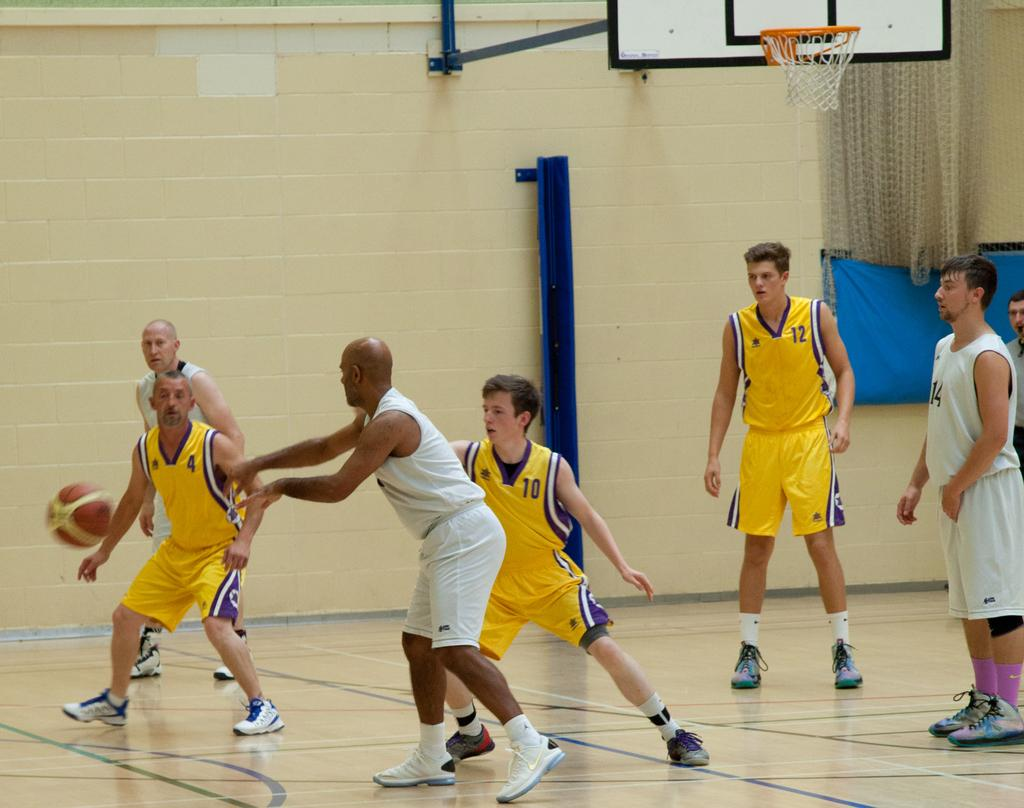How many people are in the image? There is a group of people in the image. What object is present in the image that is often used in sports? There is a ball in the image, which is commonly used in sports. What type of structure is visible in the image that is often used for basketball? There is a basketball hoop in the image. What type of architectural feature is present in the image? There is a wall in the image. What type of carriage can be seen in the image? There is no carriage present in the image. How does the group of people take a bath together in the image? There is no bath or indication of bathing in the image. 